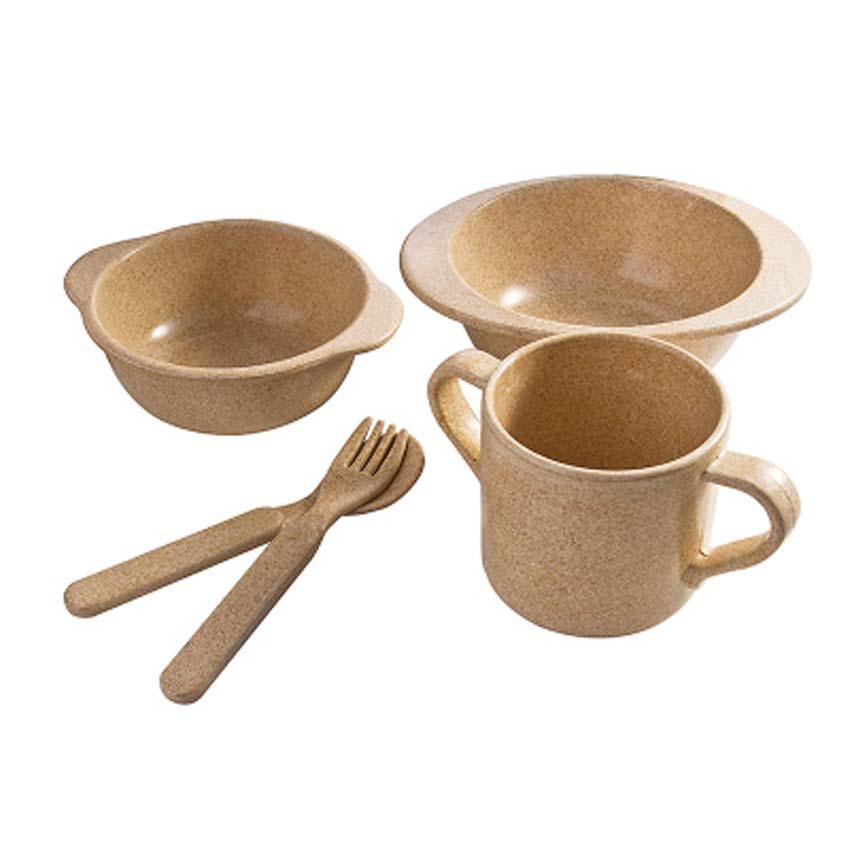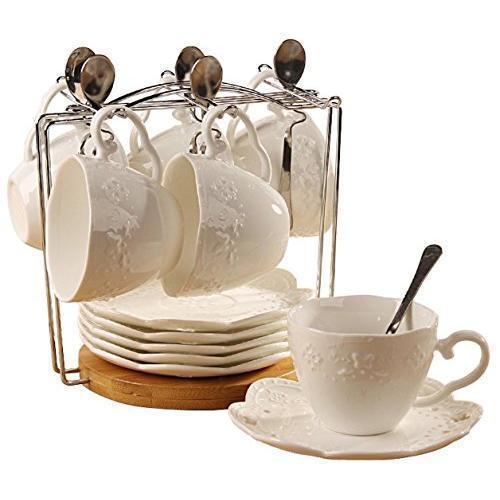The first image is the image on the left, the second image is the image on the right. For the images displayed, is the sentence "An image shows beige dishware that look like melamine plastic." factually correct? Answer yes or no. Yes. 